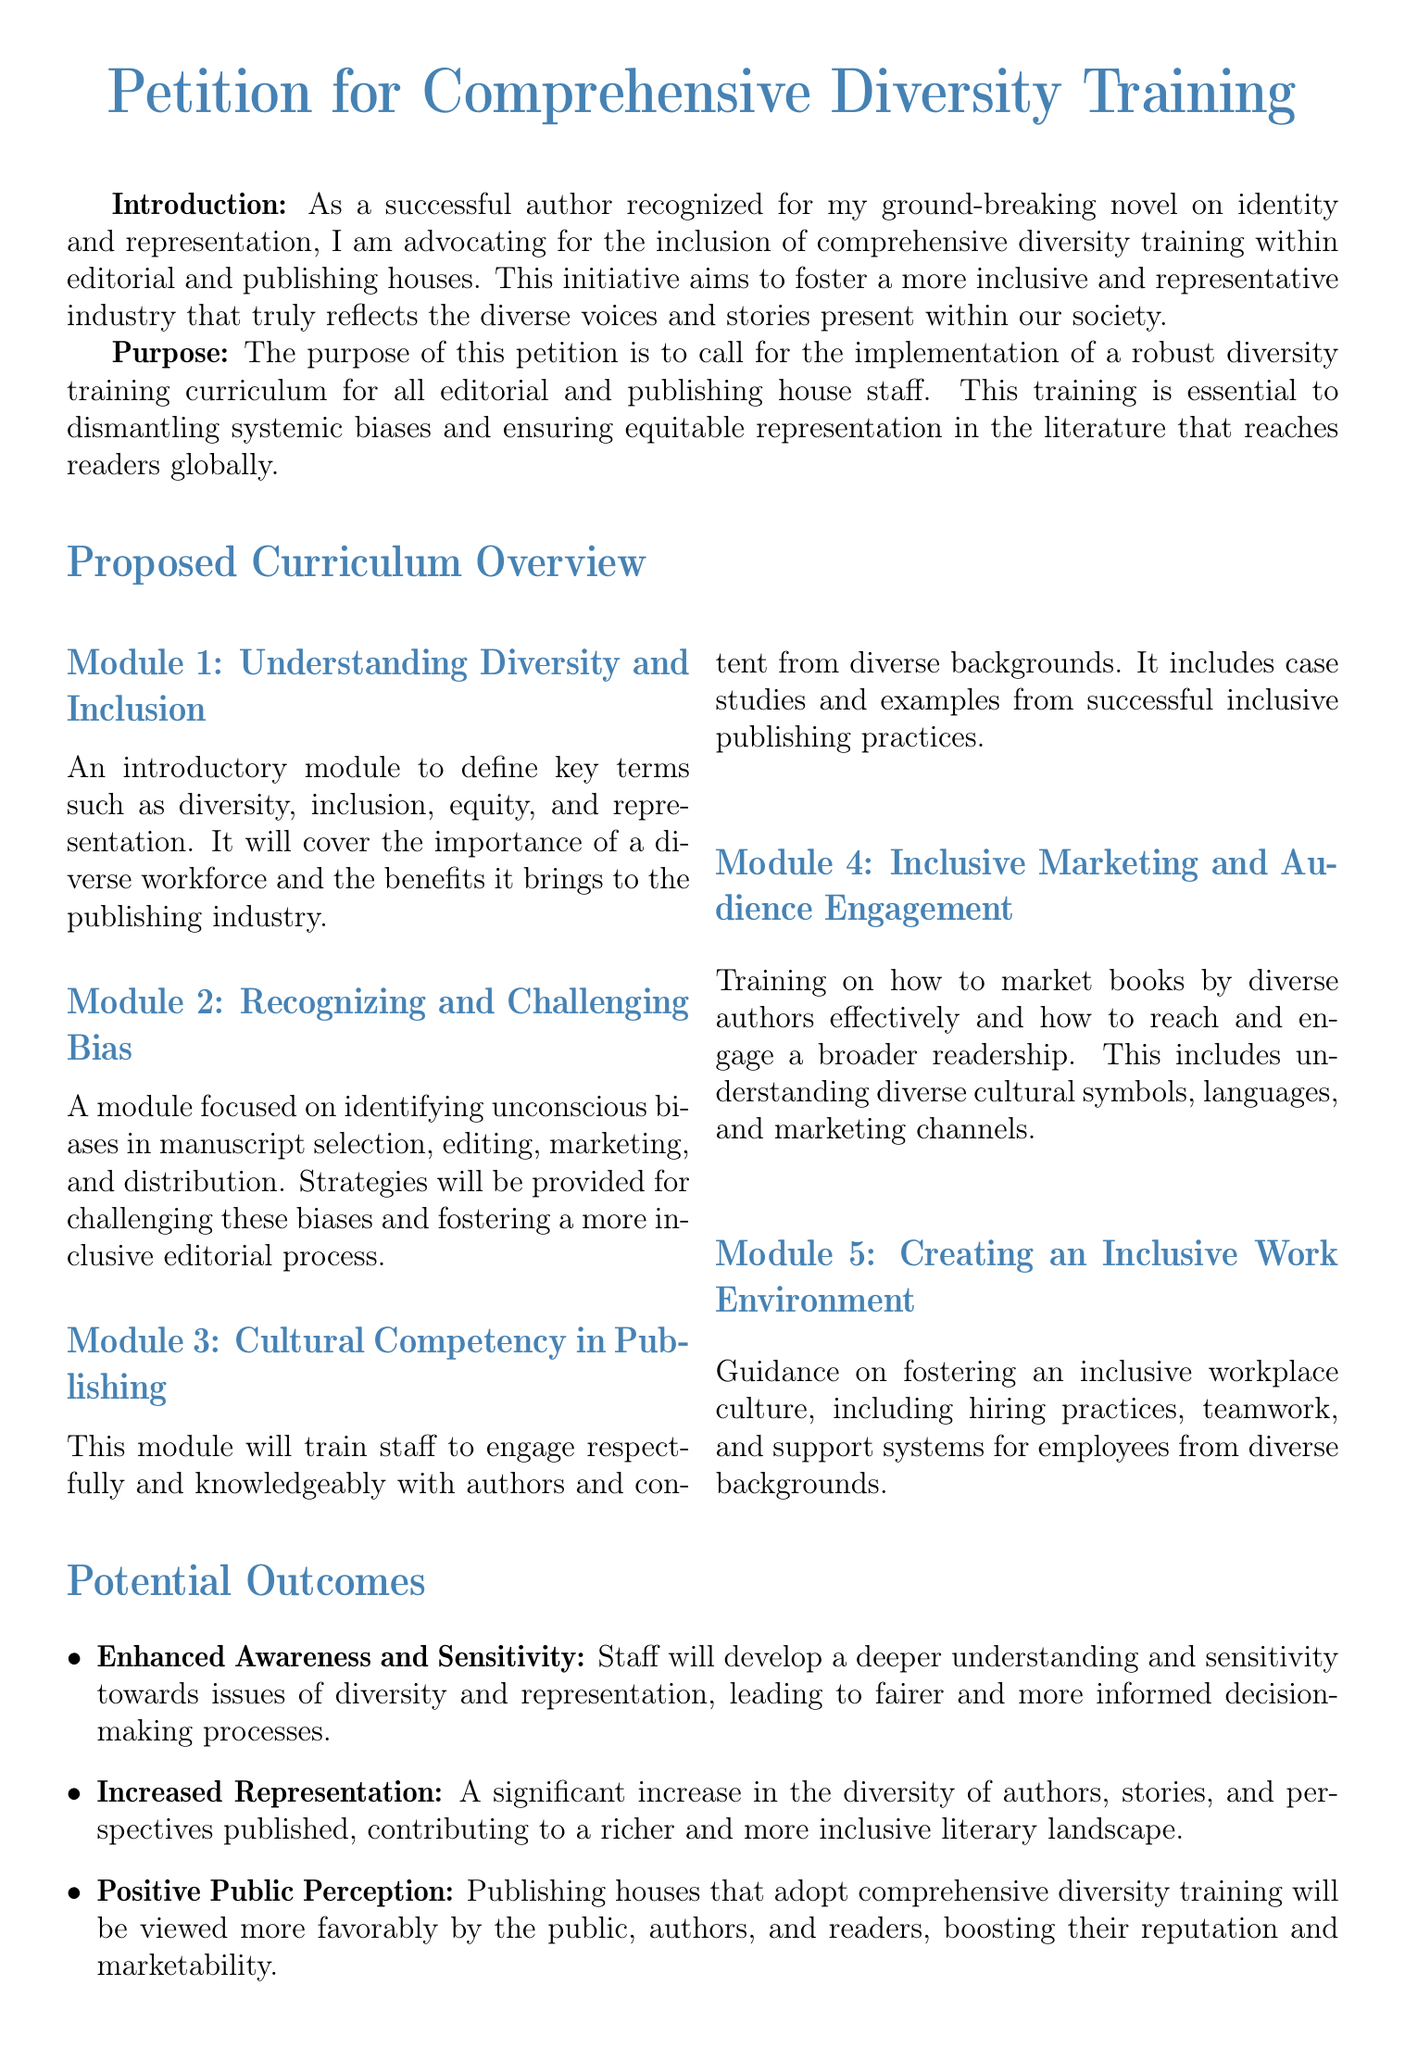what is the title of the petition? The title of the petition is presented prominently at the top of the document.
Answer: Petition for Comprehensive Diversity Training how many modules are proposed in the curriculum? The document outlines a total of five distinct modules in the proposed curriculum.
Answer: 5 what is the focus of Module 2? Module 2 addresses specific concerns related to biases and provides strategies for improvement in the editorial process.
Answer: Recognizing and Challenging Bias what is one potential outcome of the proposed training? The document lists several outcomes; one of them involves staff awareness and sensitivity towards diversity issues.
Answer: Enhanced Awareness and Sensitivity what does the conclusion of the petition emphasize? The conclusion stresses the importance of supporting diversity training for a more inclusive publishing industry.
Answer: A more inclusive publishing industry what is the purpose of the petition? The purpose details the call for a certain training implementation in the publishing houses to address biases and representation.
Answer: Implementation of a robust diversity training curriculum 